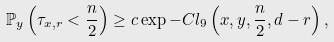Convert formula to latex. <formula><loc_0><loc_0><loc_500><loc_500>\mathbb { P } _ { y } \left ( \tau _ { x , r } < \frac { n } { 2 } \right ) \geq c \exp - C l _ { 9 } \left ( x , y , \frac { n } { 2 } , d - r \right ) ,</formula> 